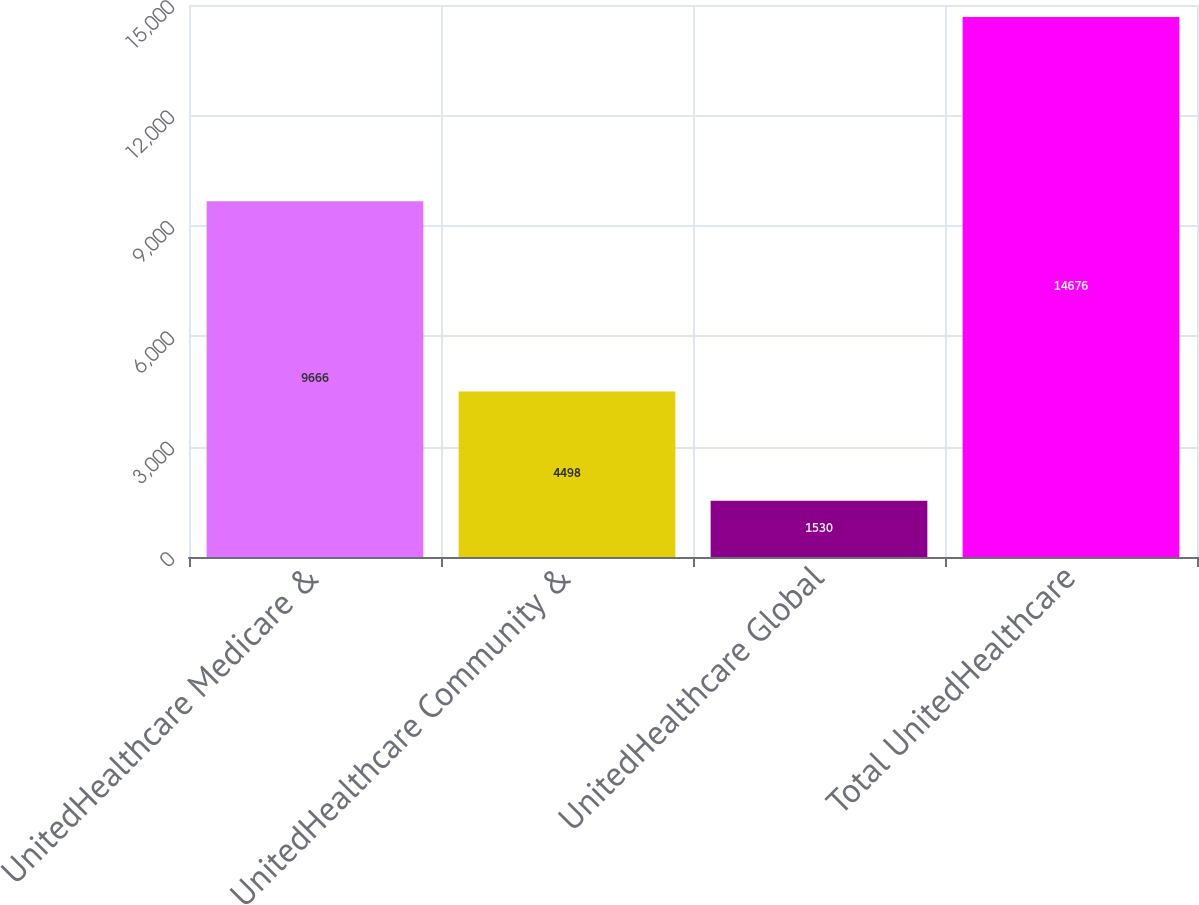Convert chart to OTSL. <chart><loc_0><loc_0><loc_500><loc_500><bar_chart><fcel>UnitedHealthcare Medicare &<fcel>UnitedHealthcare Community &<fcel>UnitedHealthcare Global<fcel>Total UnitedHealthcare<nl><fcel>9666<fcel>4498<fcel>1530<fcel>14676<nl></chart> 